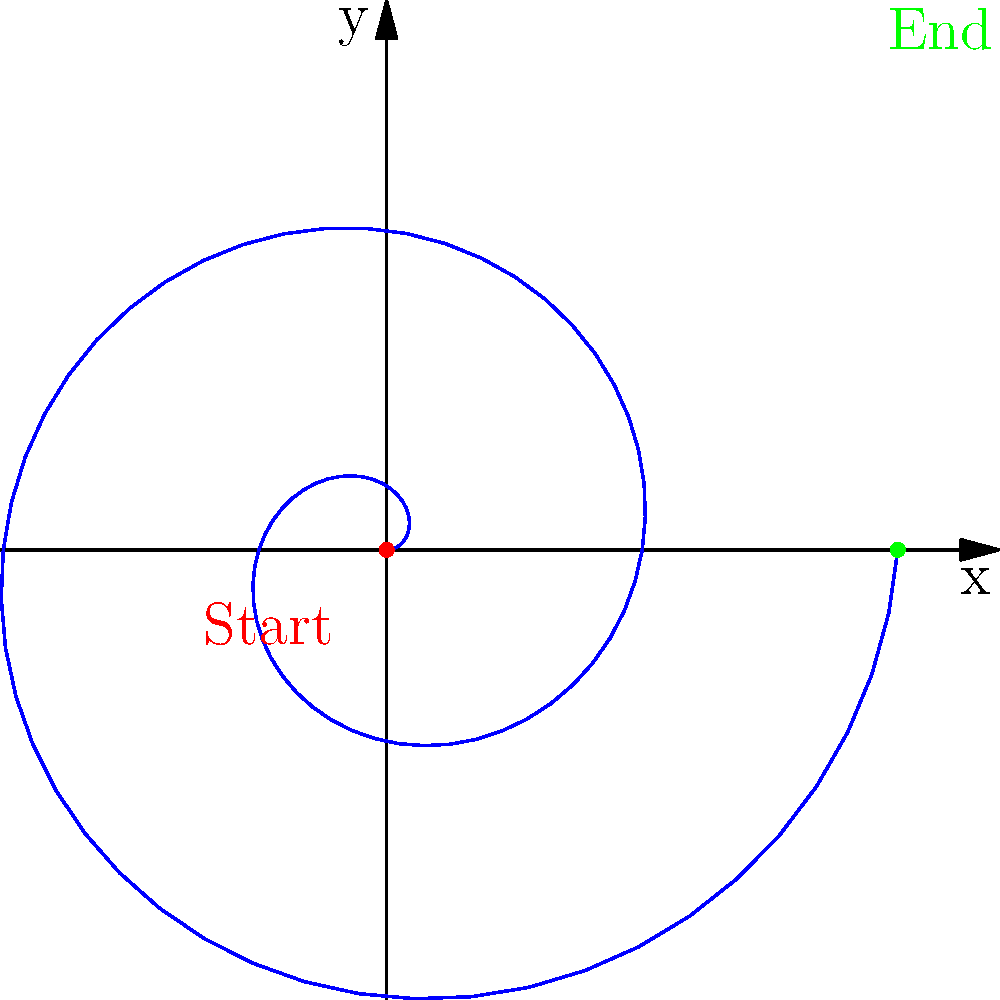In Jane Austen's "Pride and Prejudice," Elizabeth Bennet's emotional journey can be represented as a spiral path. If we plot her progression from initial prejudice to final understanding using polar coordinates, with the angle representing the passage of time and the radius representing her emotional proximity to Mr. Darcy, which direction would the spiral move? To answer this question, let's consider the following steps:

1. In polar coordinates, a spiral is represented by an equation where the radius (r) is a function of the angle (θ).

2. Elizabeth's journey in "Pride and Prejudice" starts with a strong prejudice against Mr. Darcy, which would place her emotionally distant from him.

3. As the novel progresses, Elizabeth's understanding of Mr. Darcy grows, and she becomes emotionally closer to him.

4. This progression would be represented by a decreasing distance (radius) as time (angle) increases.

5. In polar coordinates, a decreasing radius with increasing angle results in a counterclockwise spiral that moves inward towards the origin.

6. The start of the spiral (outer point) represents Elizabeth's initial prejudice, while the end (inner point) represents her final understanding and emotional proximity to Mr. Darcy.

7. In the provided diagram, the spiral moves counterclockwise from the outer blue point (labeled "Start") to the inner green point (labeled "End").

Therefore, Elizabeth's emotional journey would be represented by a counterclockwise, inward-moving spiral in polar coordinates.
Answer: Counterclockwise, inward 